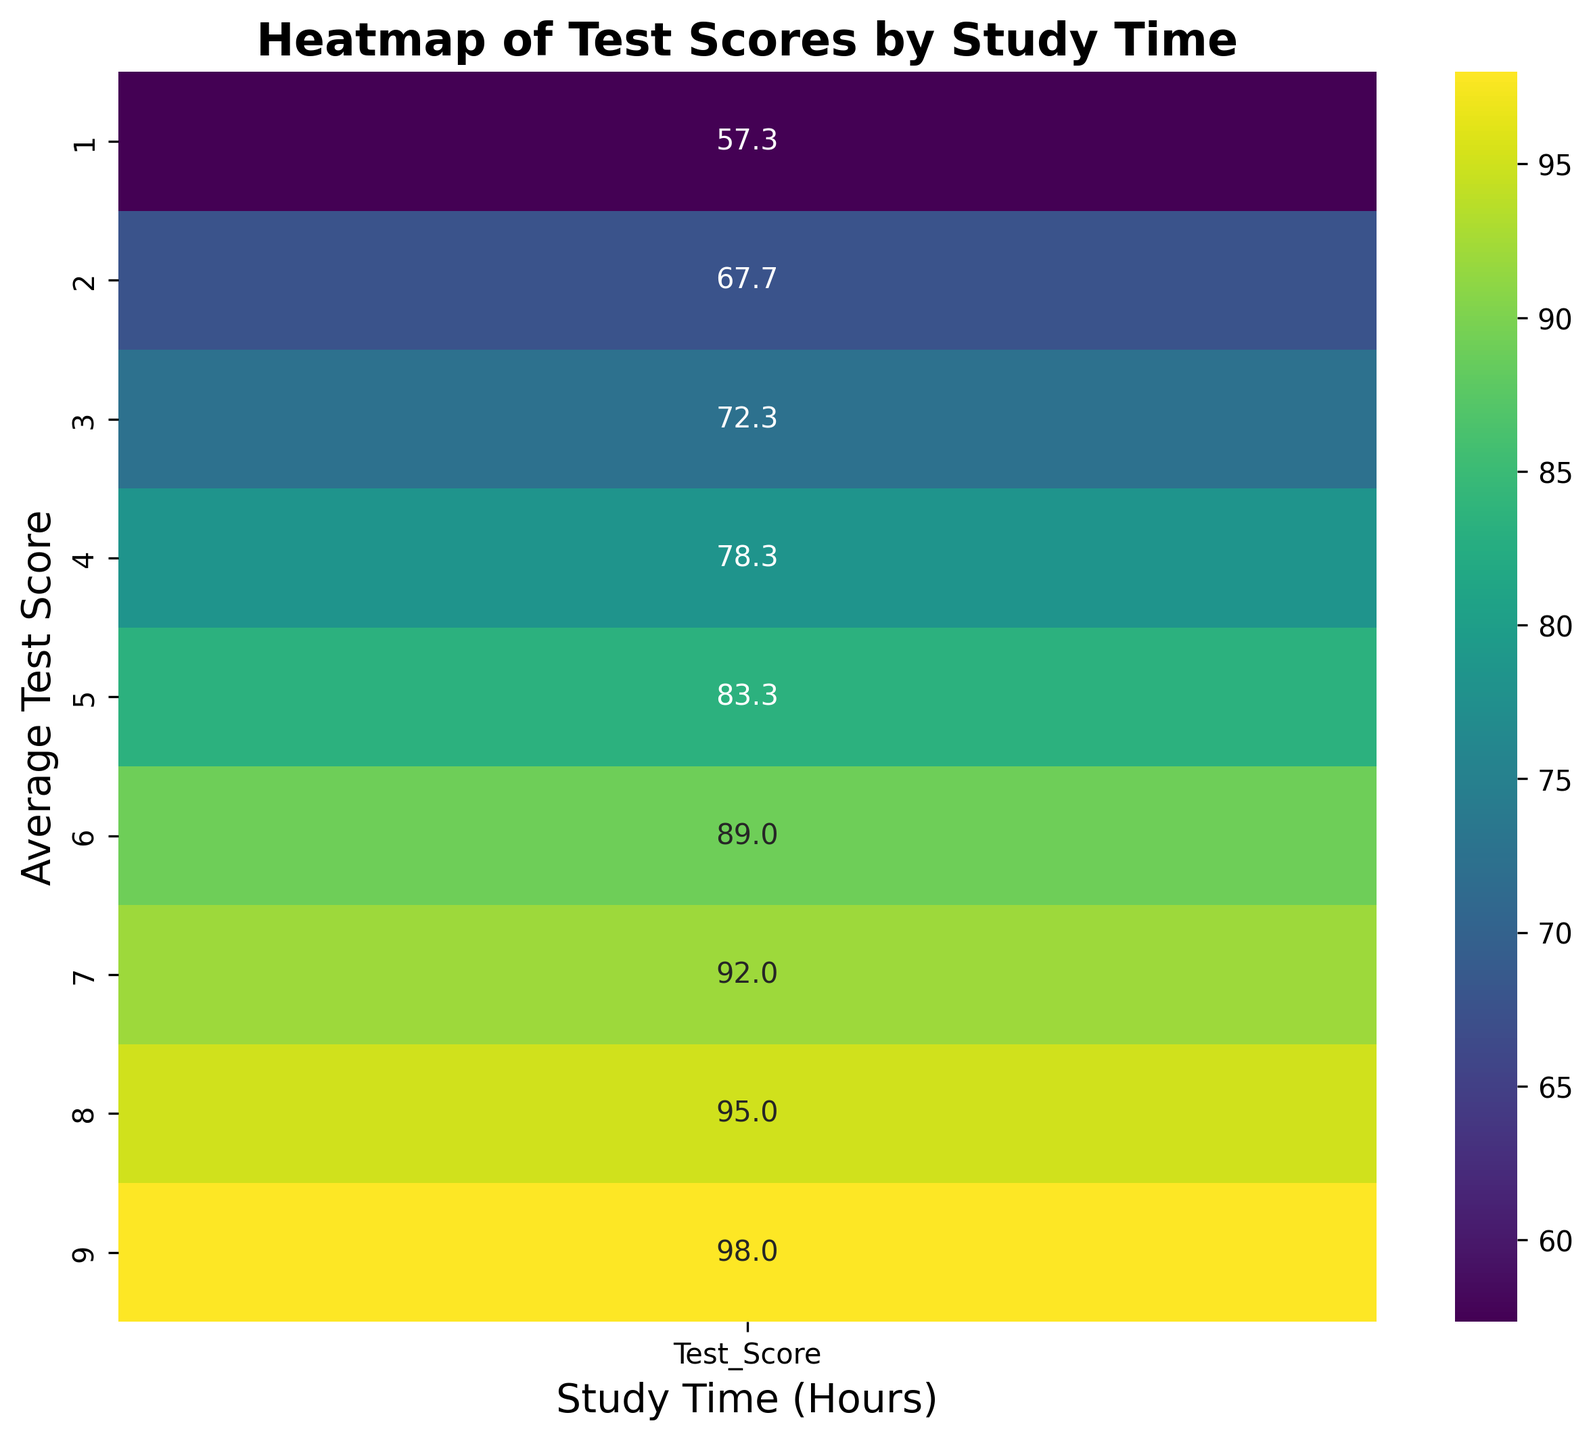What's the average test score for students who studied for 6 hours? First, locate the study time of 6 hours on the heatmap. Check the corresponding test scores and then find the average. From the heatmap, the scores at 6 hours are all very close, and the annotations will likely confirm an average around a single value.
Answer: 89 Which study time corresponds to the highest average test score? Look at the heatmap and find the highest value in the test score annotations. Then, see which study time this highest value corresponds to.
Answer: 9 hours Is there a noticeable increase in average test scores as study time increases from 1 hour to 8 hours? Observe the change in color and the annotated scores from the study time of 1 hour to 8 hours in the heatmap. Notice if the scores generally increase as the study time increases.
Answer: Yes Which study time has a lower average test score: 2 hours or 5 hours? Compare the annotated scores of the 2-hour study time and the 5-hour study time. The one with the lower score will identify the answer.
Answer: 2 hours What is the test score range for a study time of 4 hours? Find the scores for the 4-hour study time on the heatmap. Calculate the range by subtracting the smallest score from the largest score.
Answer: 78-80 At which study times do students score at least 90 on average? Look at the annotated scores and identify which study times have an average score of 90 or above.
Answer: 6, 7, 8, 9 hours How does the average test score change between 3 hours and 6 hours of study time? Compare the annotated scores at 3 hours of study time and those at 6 hours of study time to determine if there is an increase or decrease.
Answer: Increase Is there any study time where the average test score is below 60? Check the heatmap for any annotated scores lower than 60 and identify the corresponding study times.
Answer: No 